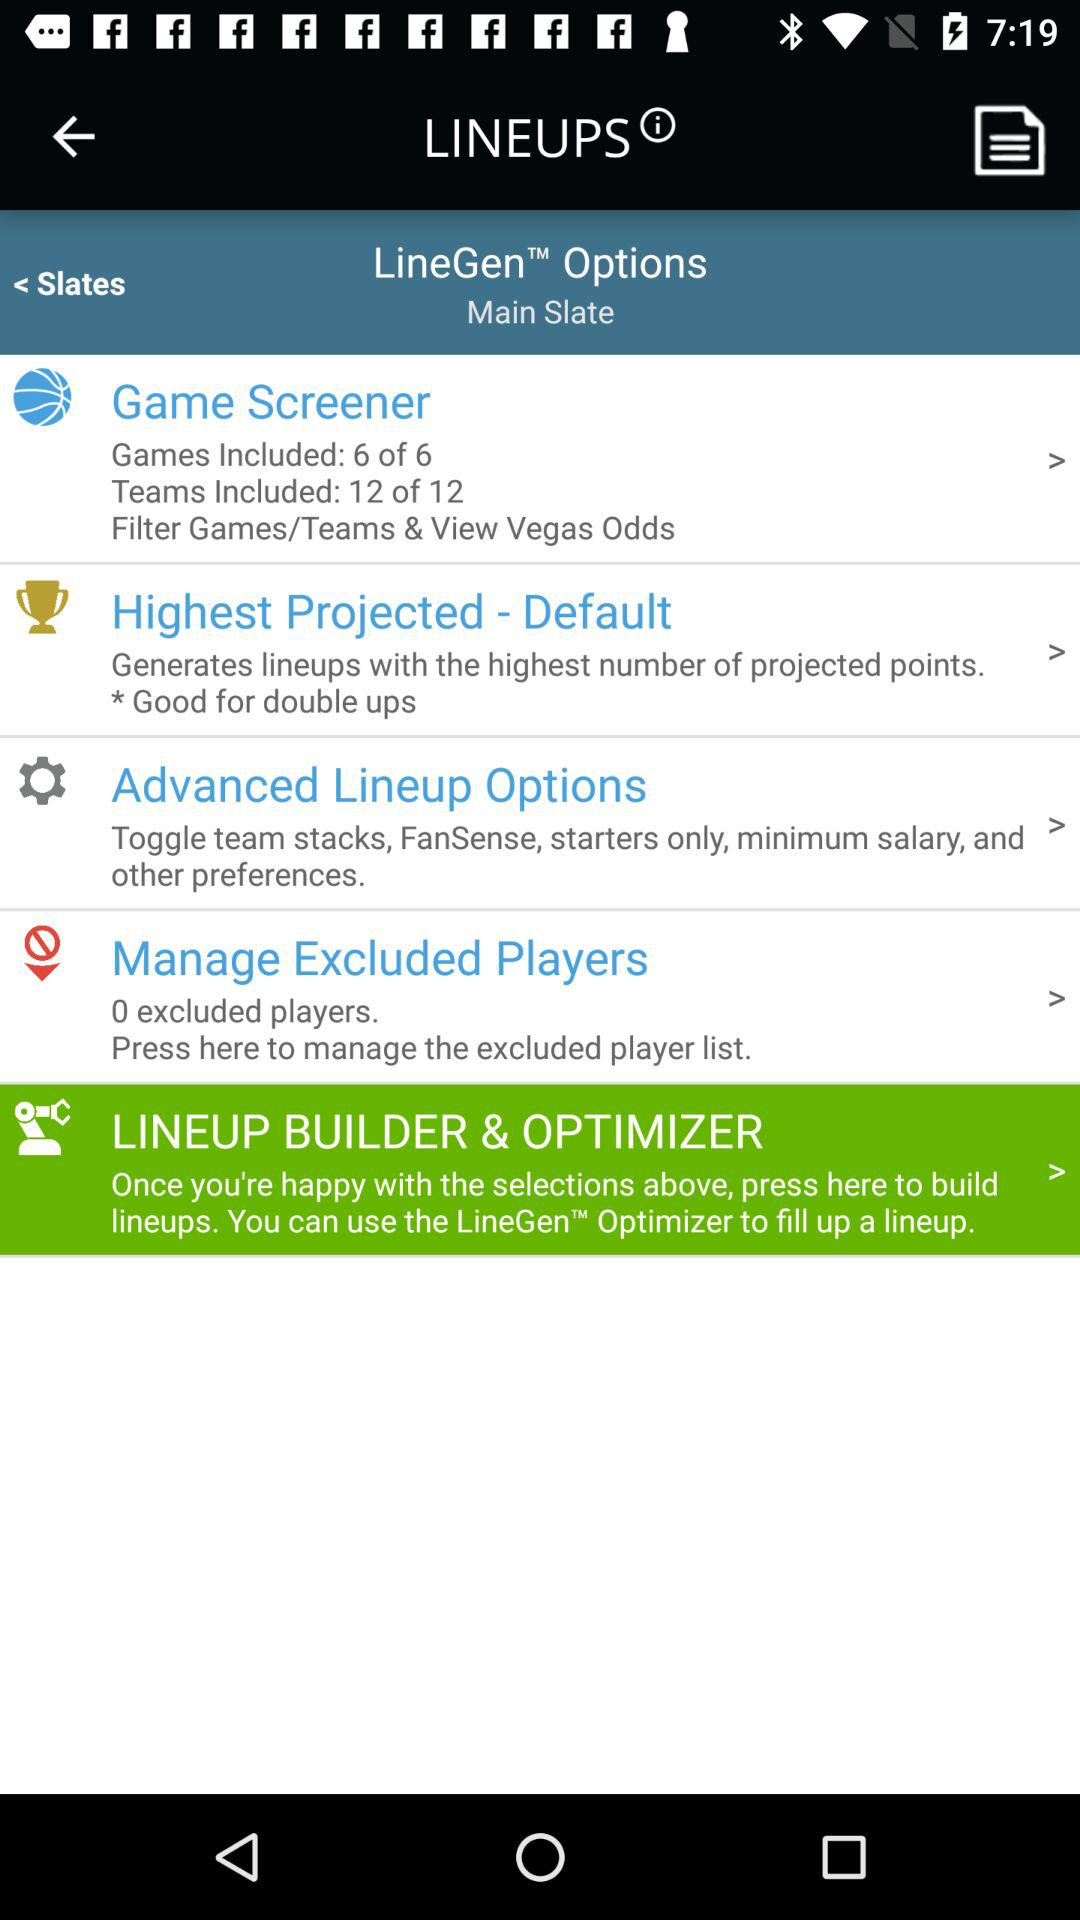What are the advanced lineup options? The advanced lineup options are toggle team stacks, FanSense, starters only, minimum salary, and other preferences. 